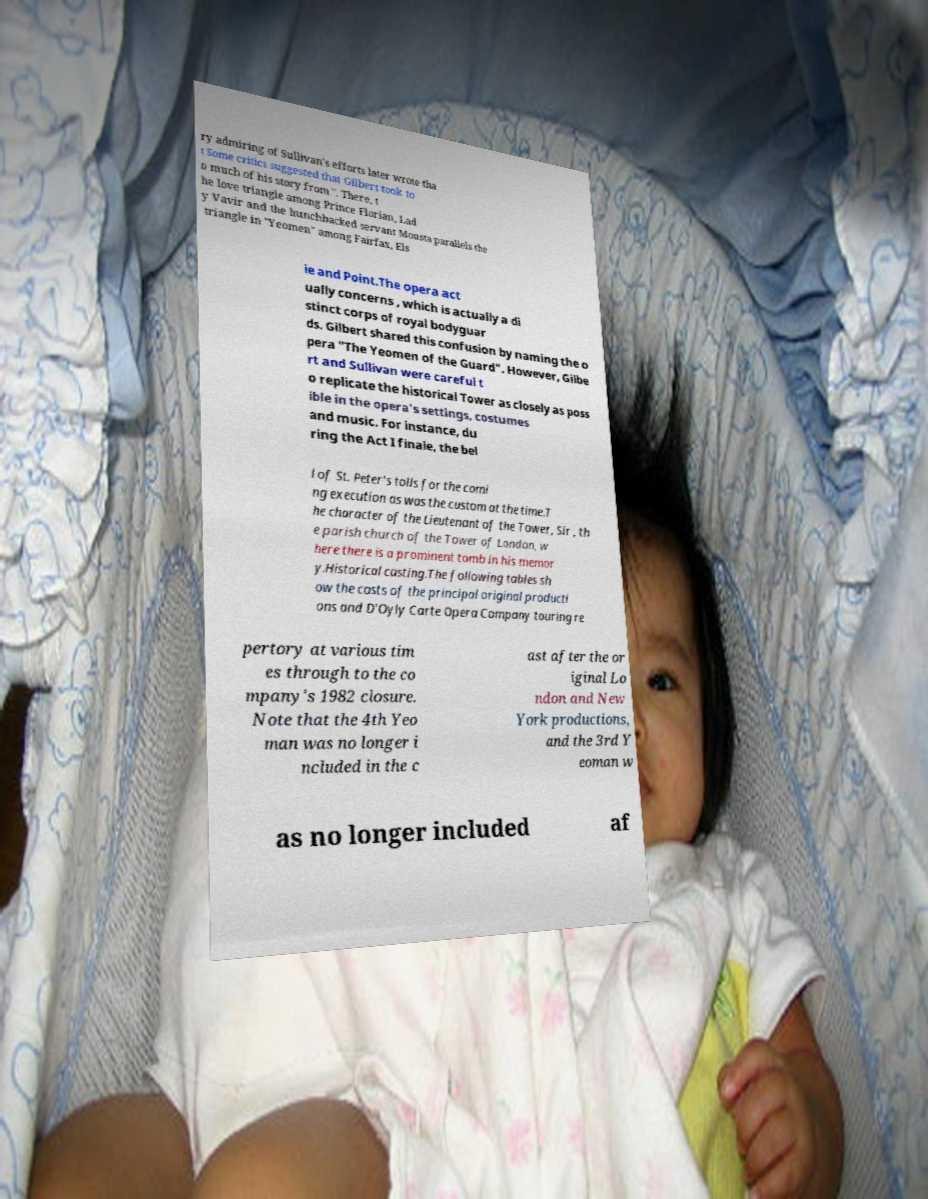Can you accurately transcribe the text from the provided image for me? ry admiring of Sullivan's efforts later wrote tha t Some critics suggested that Gilbert took to o much of his story from ". There, t he love triangle among Prince Florian, Lad y Vavir and the hunchbacked servant Mousta parallels the triangle in "Yeomen" among Fairfax, Els ie and Point.The opera act ually concerns , which is actually a di stinct corps of royal bodyguar ds. Gilbert shared this confusion by naming the o pera "The Yeomen of the Guard". However, Gilbe rt and Sullivan were careful t o replicate the historical Tower as closely as poss ible in the opera's settings, costumes and music. For instance, du ring the Act I finale, the bel l of St. Peter's tolls for the comi ng execution as was the custom at the time.T he character of the Lieutenant of the Tower, Sir , th e parish church of the Tower of London, w here there is a prominent tomb in his memor y.Historical casting.The following tables sh ow the casts of the principal original producti ons and D'Oyly Carte Opera Company touring re pertory at various tim es through to the co mpany's 1982 closure. Note that the 4th Yeo man was no longer i ncluded in the c ast after the or iginal Lo ndon and New York productions, and the 3rd Y eoman w as no longer included af 